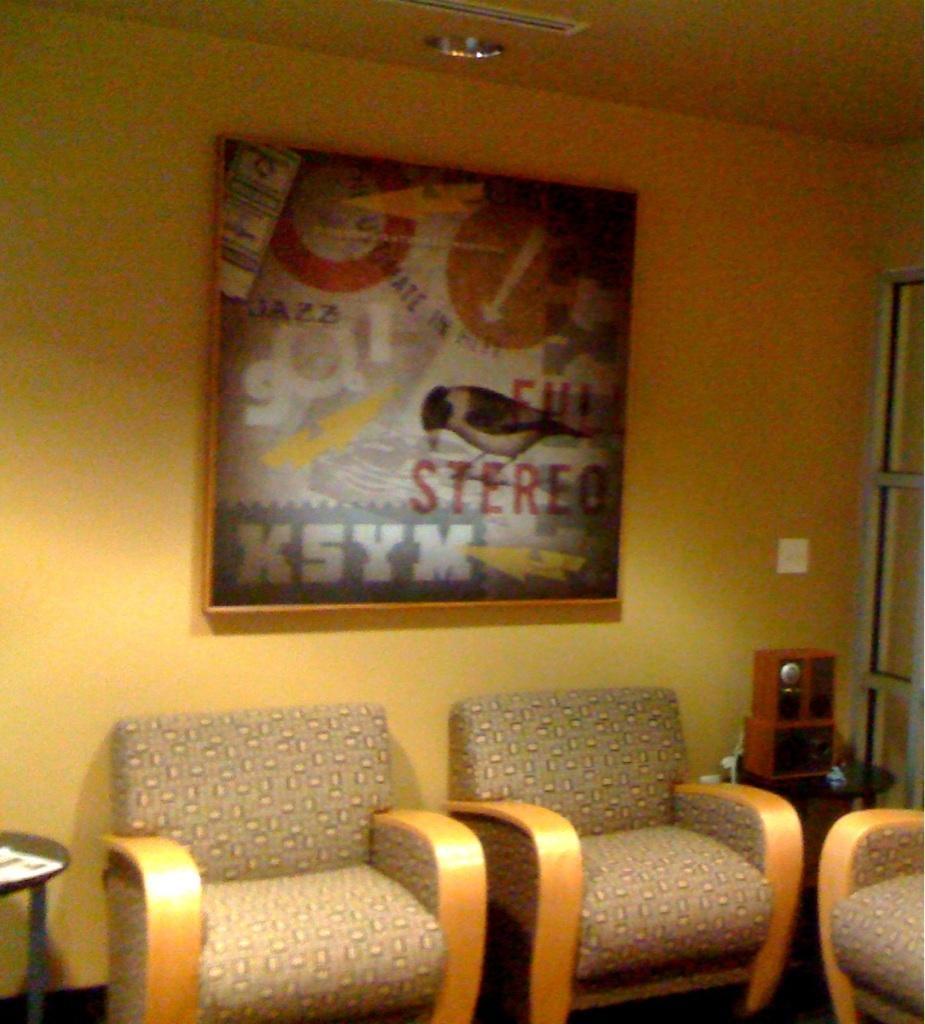Could you give a brief overview of what you see in this image? In this image we can see an inner view of a room containing some chairs, a table, a box which is placed on the table, a photo frame and a switch board on the wall and a roof with some ceiling lights. 